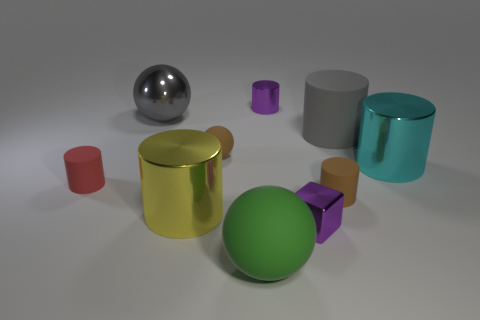Subtract 3 cylinders. How many cylinders are left? 3 Subtract all brown cylinders. How many cylinders are left? 5 Subtract all brown cylinders. How many cylinders are left? 5 Subtract all green cylinders. Subtract all purple blocks. How many cylinders are left? 6 Subtract all balls. How many objects are left? 7 Add 1 brown matte spheres. How many brown matte spheres exist? 2 Subtract 1 yellow cylinders. How many objects are left? 9 Subtract all small purple metal blocks. Subtract all blue matte cubes. How many objects are left? 9 Add 3 cylinders. How many cylinders are left? 9 